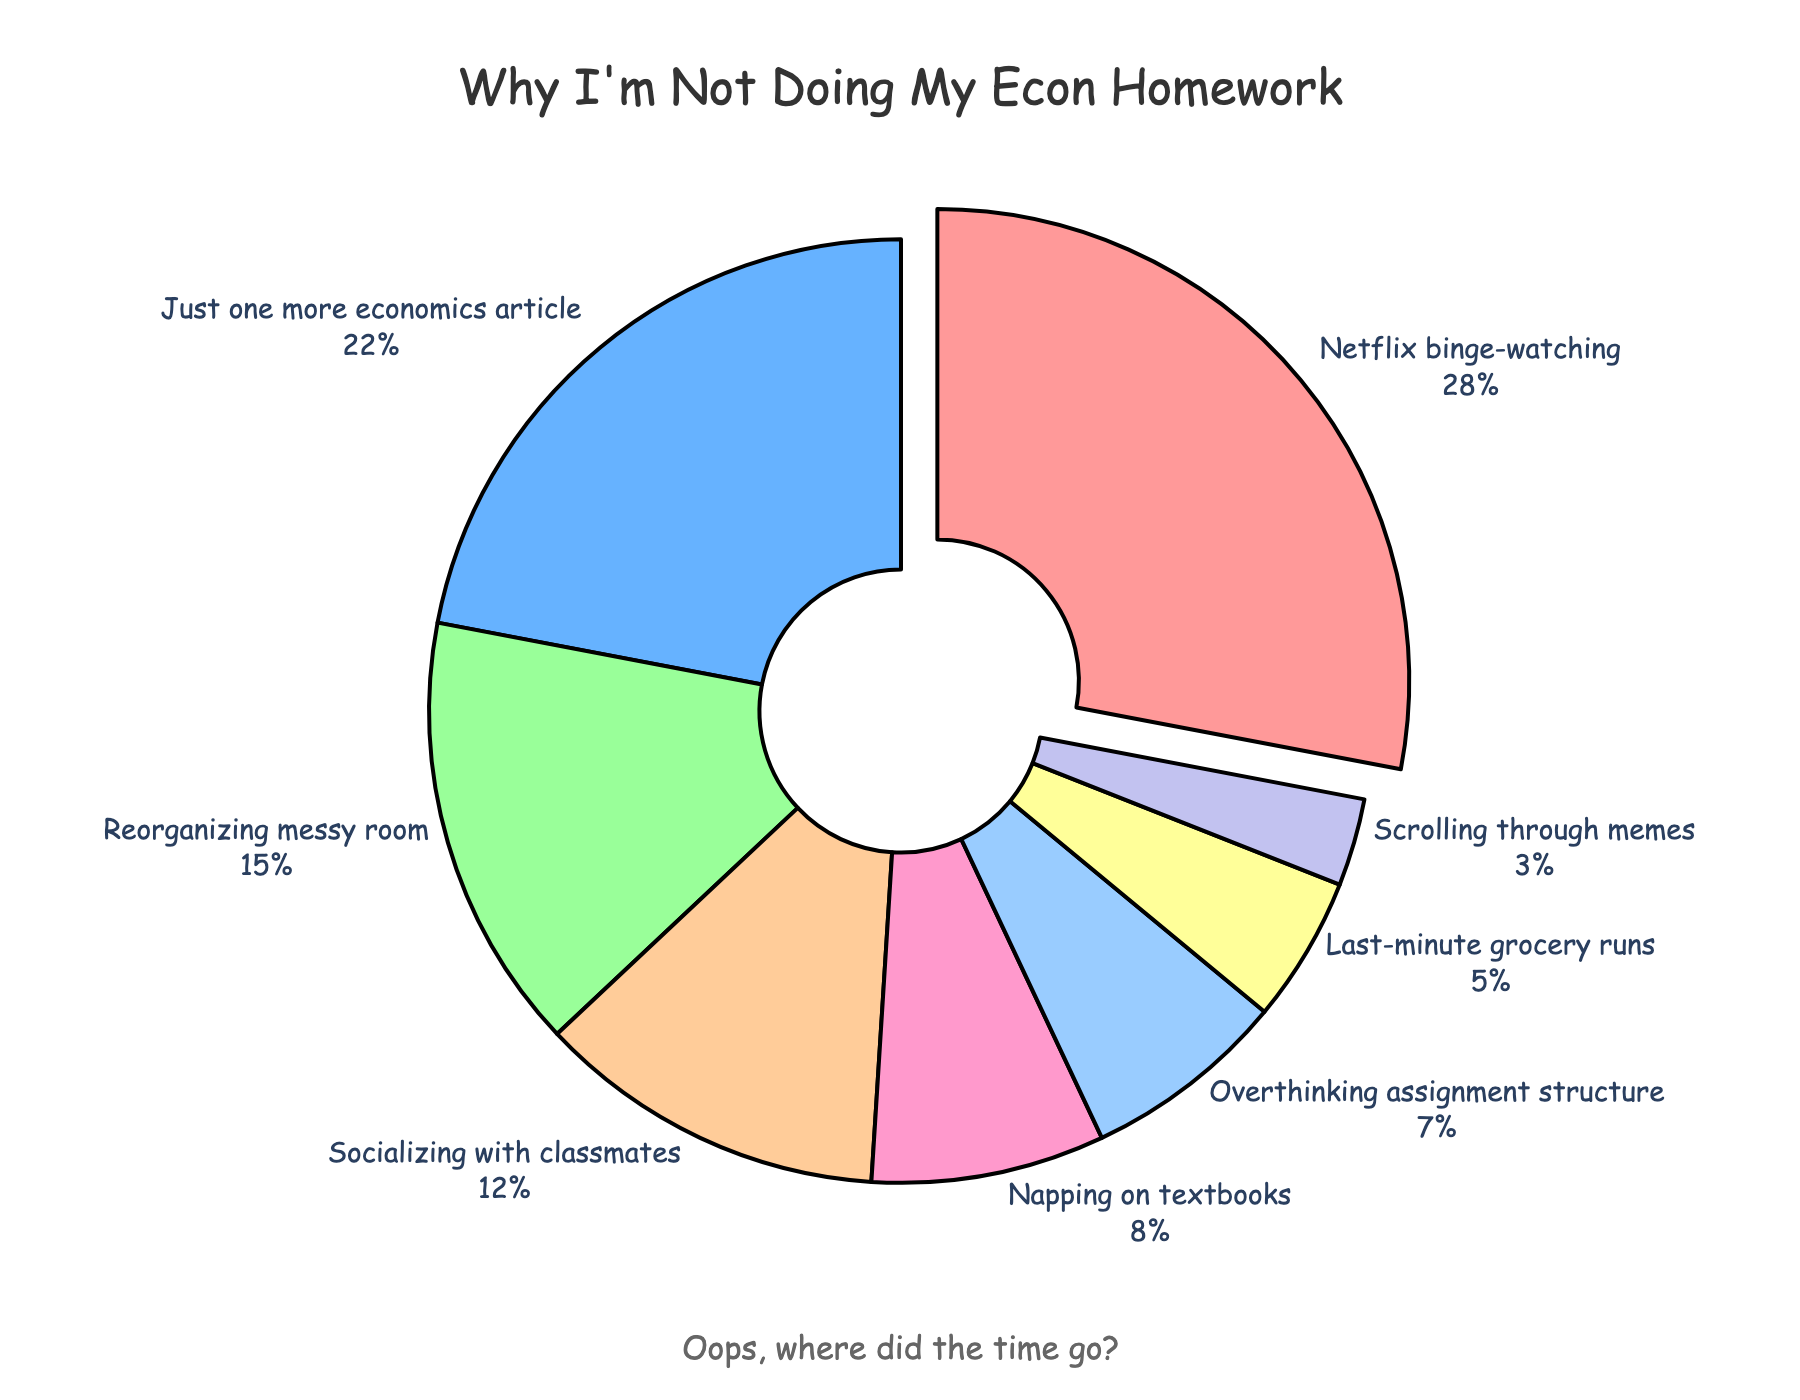What percentage of students procrastinate by socializing with classmates? Look at the segment labeled "Socializing with classmates" and read the percentage value.
Answer: 12% Which procrastination reason has the second highest percentage? Identify the segments in the pie chart and compare their percentages. "Just one more" economics article has 22%, which is second highest after Netflix binge-watching.
Answer: "Just one more" economics article What is the combined percentage of students procrastinating by scrolling through memes and grocery runs? Find the segments labeled "Scrolling through memes" and "Last-minute grocery runs". Sum their percentage values, 3% + 5%.
Answer: 8% Is the percentage of students Netflix binge-watching greater than the combined percentage of those napping on textbooks and overthinking assignment structure? Compare the percentage for "Netflix binge-watching" (28%) with the combined percentage of "Napping on textbooks" (8%) and "Overthinking assignment structure" (7%), which is 15%. Since 28% > 15%, the answer is yes.
Answer: Yes What color is the segment representing reorganizing a messy room? Look at the segment labeled "Reorganizing messy room" and identify its color.
Answer: Green How much larger is the percentage of students binge-watching Netflix compared to overthinking assignment structure? Subtract the percentage of "Overthinking assignment structure" (7%) from "Netflix binge-watching" (28%), which is 28% - 7%.
Answer: 21% Which slice of the pie chart is pulled out from the center? Identify the segment that appears separated from the rest of the pie chart.
Answer: Netflix binge-watching Which three reasons have the lowest percentages? Identify the three smallest segments by percentages, they are "Scrolling through memes" (3%), "Last-minute grocery runs" (5%), and "Overthinking assignment structure" (7%).
Answer: "Scrolling through memes", "Last-minute grocery runs", "Overthinking assignment structure" Is the percentage of students socializing with classmates greater than those reorganizing their messy room? Compare the percentage for "Socializing with classmates" (12%) with "Reorganizing messy room" (15%). Since 12% < 15%, the answer is no.
Answer: No 